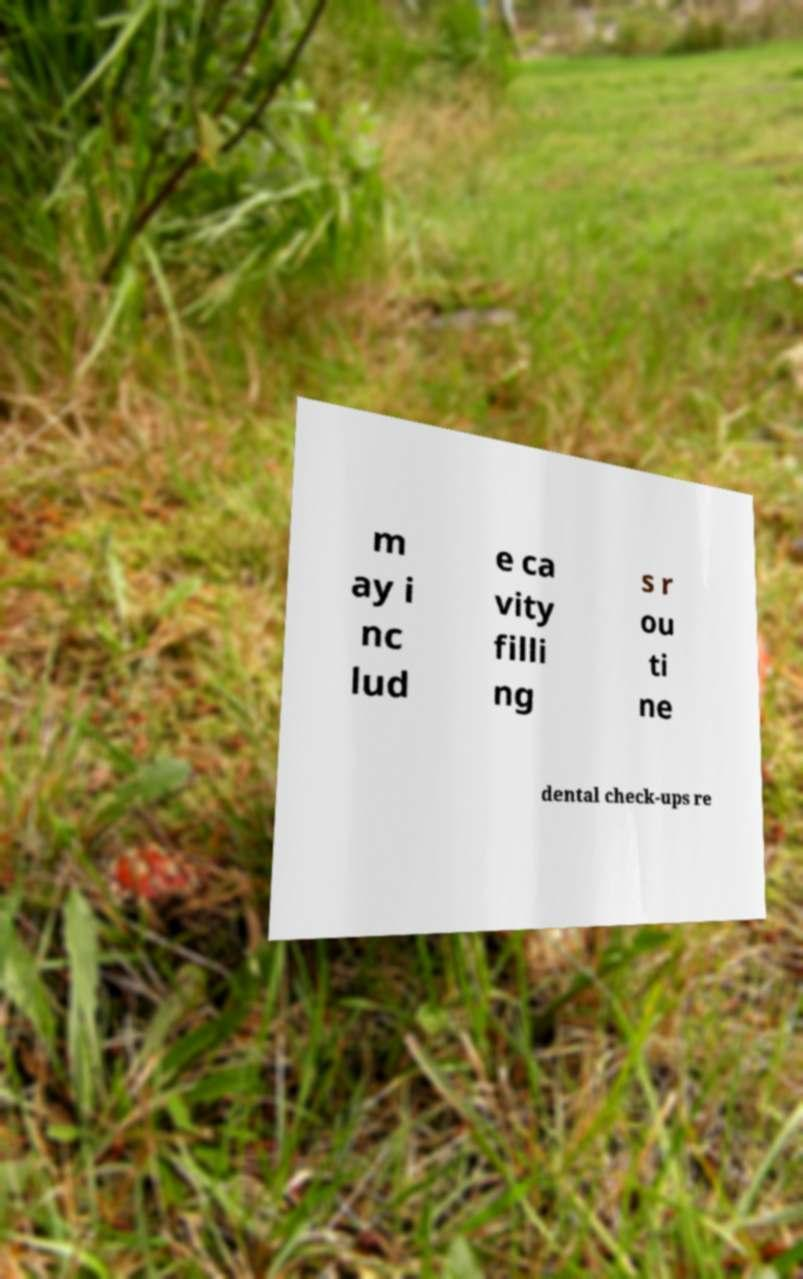For documentation purposes, I need the text within this image transcribed. Could you provide that? m ay i nc lud e ca vity filli ng s r ou ti ne dental check-ups re 